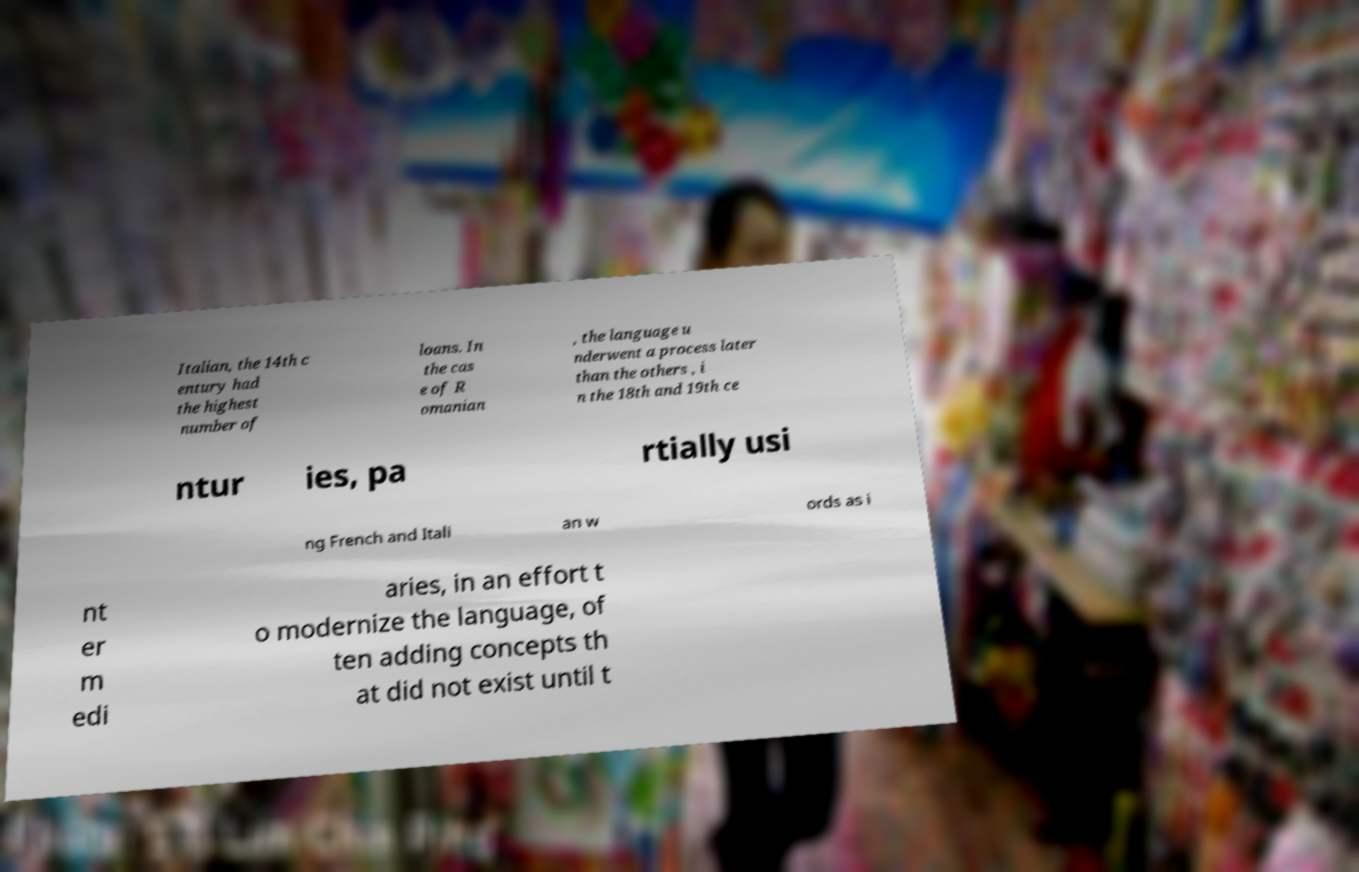Please read and relay the text visible in this image. What does it say? Italian, the 14th c entury had the highest number of loans. In the cas e of R omanian , the language u nderwent a process later than the others , i n the 18th and 19th ce ntur ies, pa rtially usi ng French and Itali an w ords as i nt er m edi aries, in an effort t o modernize the language, of ten adding concepts th at did not exist until t 